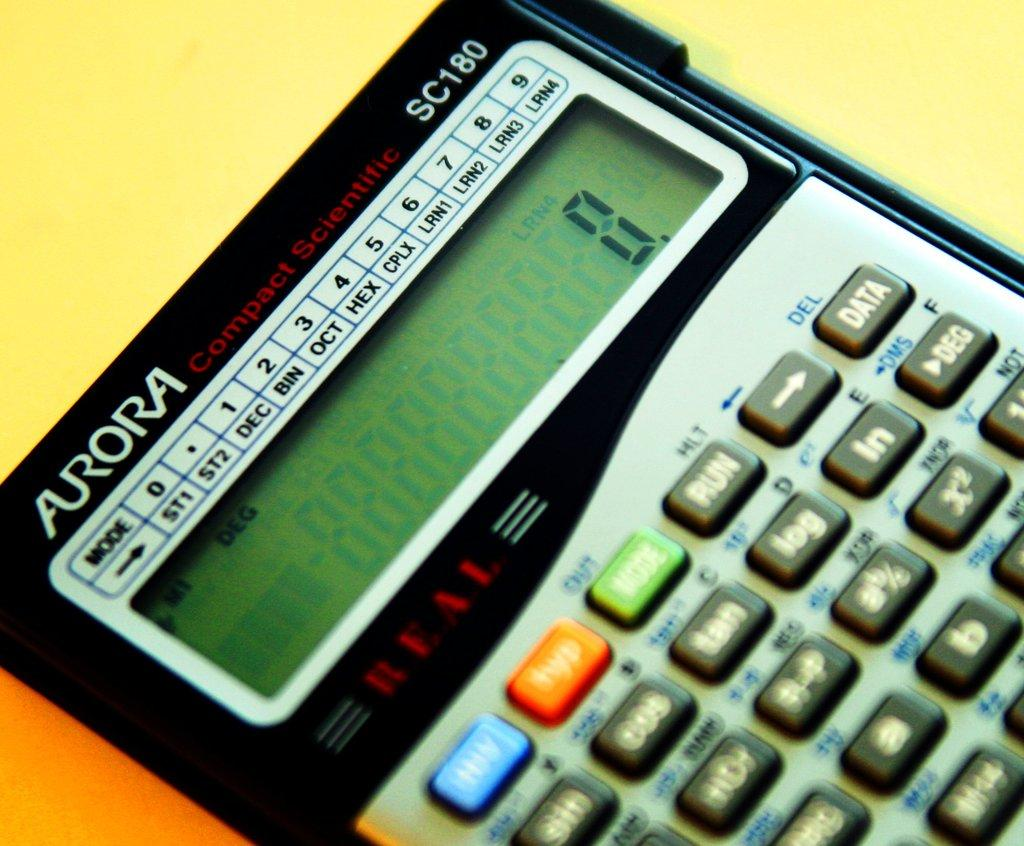<image>
Share a concise interpretation of the image provided. Aurora Compact Scientific SC180 is the model number shown on this calculator. 